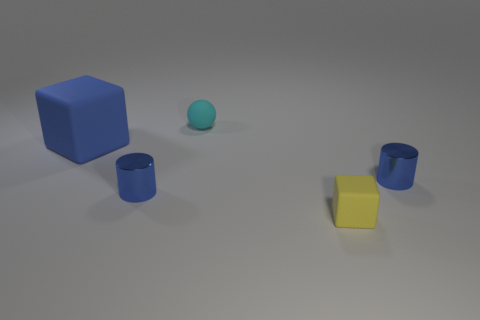Is the material of the tiny yellow cube right of the cyan rubber thing the same as the small blue thing that is right of the yellow thing?
Give a very brief answer. No. There is a tiny thing that is the same shape as the big object; what material is it?
Keep it short and to the point. Rubber. There is a small matte thing that is behind the cylinder left of the tiny ball; what is its color?
Give a very brief answer. Cyan. The blue block that is the same material as the tiny ball is what size?
Offer a terse response. Large. What number of other tiny objects are the same shape as the blue rubber object?
Provide a succinct answer. 1. What number of things are blue objects in front of the big blue object or things behind the big blue matte thing?
Provide a succinct answer. 3. How many blue rubber blocks are to the left of the object behind the big blue thing?
Provide a short and direct response. 1. Does the matte thing in front of the big blue rubber block have the same shape as the big blue thing that is to the left of the yellow rubber cube?
Your answer should be compact. Yes. Is there a large blue cube that has the same material as the tiny cyan thing?
Keep it short and to the point. Yes. How many metallic objects are blue cubes or small blue cylinders?
Ensure brevity in your answer.  2. 